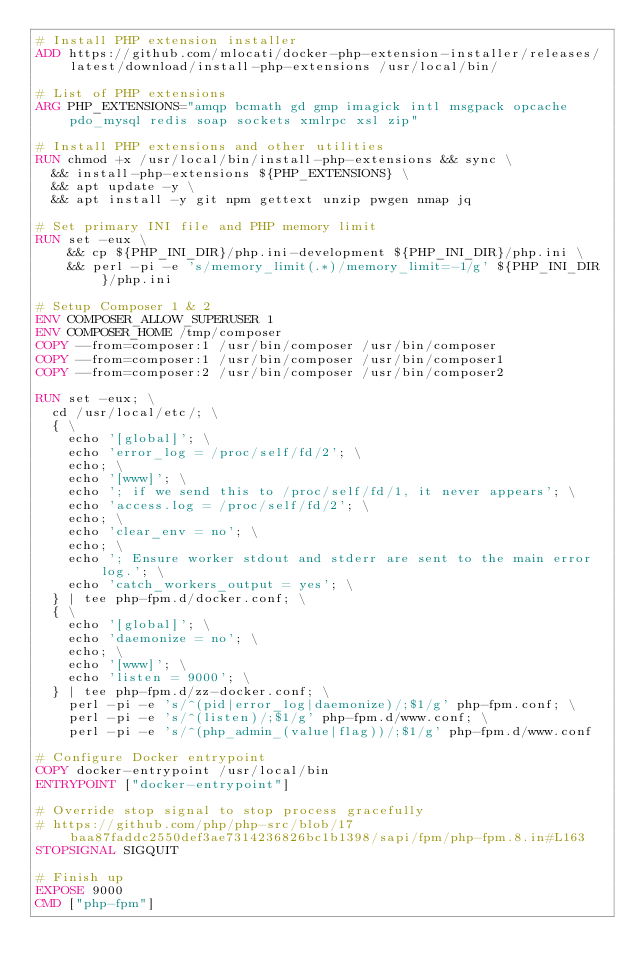Convert code to text. <code><loc_0><loc_0><loc_500><loc_500><_Dockerfile_># Install PHP extension installer
ADD https://github.com/mlocati/docker-php-extension-installer/releases/latest/download/install-php-extensions /usr/local/bin/

# List of PHP extensions
ARG PHP_EXTENSIONS="amqp bcmath gd gmp imagick intl msgpack opcache pdo_mysql redis soap sockets xmlrpc xsl zip"

# Install PHP extensions and other utilities
RUN chmod +x /usr/local/bin/install-php-extensions && sync \
	&& install-php-extensions ${PHP_EXTENSIONS} \
	&& apt update -y \
	&& apt install -y git npm gettext unzip pwgen nmap jq

# Set primary INI file and PHP memory limit
RUN set -eux \
    && cp ${PHP_INI_DIR}/php.ini-development ${PHP_INI_DIR}/php.ini \
    && perl -pi -e 's/memory_limit(.*)/memory_limit=-1/g' ${PHP_INI_DIR}/php.ini

# Setup Composer 1 & 2
ENV COMPOSER_ALLOW_SUPERUSER 1
ENV COMPOSER_HOME /tmp/composer
COPY --from=composer:1 /usr/bin/composer /usr/bin/composer
COPY --from=composer:1 /usr/bin/composer /usr/bin/composer1
COPY --from=composer:2 /usr/bin/composer /usr/bin/composer2

RUN set -eux; \
	cd /usr/local/etc/; \
	{ \
		echo '[global]'; \
		echo 'error_log = /proc/self/fd/2'; \
		echo; \
		echo '[www]'; \
		echo '; if we send this to /proc/self/fd/1, it never appears'; \
		echo 'access.log = /proc/self/fd/2'; \
		echo; \
		echo 'clear_env = no'; \
		echo; \
		echo '; Ensure worker stdout and stderr are sent to the main error log.'; \
		echo 'catch_workers_output = yes'; \
	} | tee php-fpm.d/docker.conf; \
	{ \
		echo '[global]'; \
		echo 'daemonize = no'; \
		echo; \
		echo '[www]'; \
		echo 'listen = 9000'; \
	} | tee php-fpm.d/zz-docker.conf; \
    perl -pi -e 's/^(pid|error_log|daemonize)/;$1/g' php-fpm.conf; \
    perl -pi -e 's/^(listen)/;$1/g' php-fpm.d/www.conf; \
    perl -pi -e 's/^(php_admin_(value|flag))/;$1/g' php-fpm.d/www.conf

# Configure Docker entrypoint
COPY docker-entrypoint /usr/local/bin
ENTRYPOINT ["docker-entrypoint"]

# Override stop signal to stop process gracefully
# https://github.com/php/php-src/blob/17baa87faddc2550def3ae7314236826bc1b1398/sapi/fpm/php-fpm.8.in#L163
STOPSIGNAL SIGQUIT

# Finish up
EXPOSE 9000
CMD ["php-fpm"]
</code> 